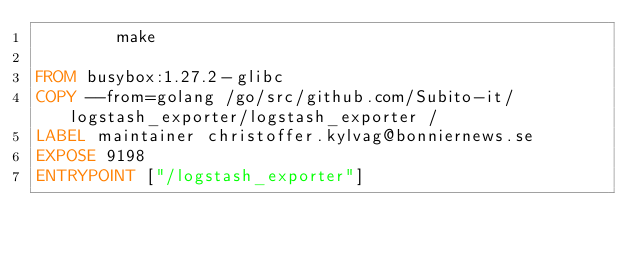<code> <loc_0><loc_0><loc_500><loc_500><_Dockerfile_>        make

FROM busybox:1.27.2-glibc
COPY --from=golang /go/src/github.com/Subito-it/logstash_exporter/logstash_exporter /
LABEL maintainer christoffer.kylvag@bonniernews.se
EXPOSE 9198
ENTRYPOINT ["/logstash_exporter"]
</code> 